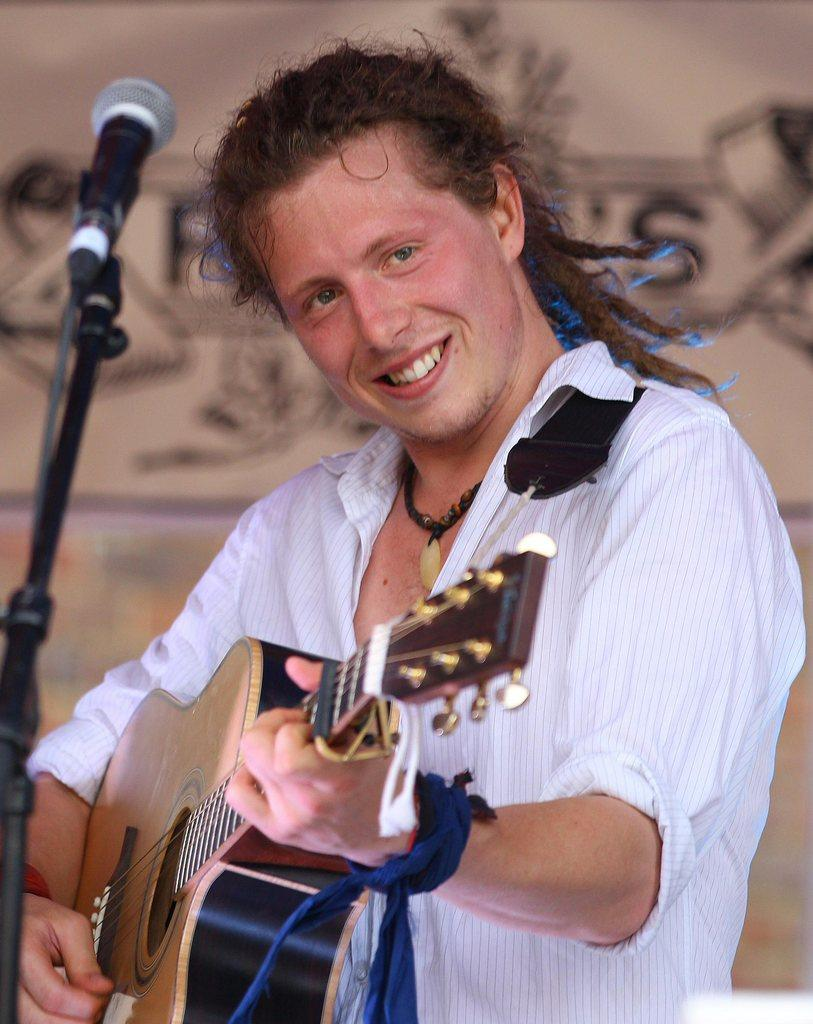What type of structure is present in the image? There is a wall in the image. What object related to sound can be seen in the image? There is a mic in the image. Who is present in the image? There is a man in the image. What is the man holding in the image? The man is holding a guitar. What type of string is used to tie the man's shoes in the image? There is no information about the man's shoes or the type of string used in the image. What type of business is being conducted in the image? There is no indication of any business activity in the image. 